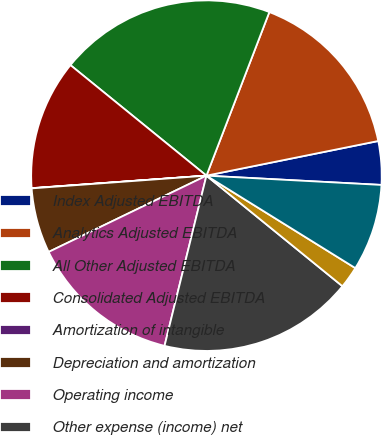Convert chart to OTSL. <chart><loc_0><loc_0><loc_500><loc_500><pie_chart><fcel>Index Adjusted EBITDA<fcel>Analytics Adjusted EBITDA<fcel>All Other Adjusted EBITDA<fcel>Consolidated Adjusted EBITDA<fcel>Amortization of intangible<fcel>Depreciation and amortization<fcel>Operating income<fcel>Other expense (income) net<fcel>Provision for income taxes<fcel>Income from continuing<nl><fcel>4.01%<fcel>15.99%<fcel>19.98%<fcel>12.0%<fcel>0.02%<fcel>6.01%<fcel>13.99%<fcel>17.98%<fcel>2.02%<fcel>8.0%<nl></chart> 